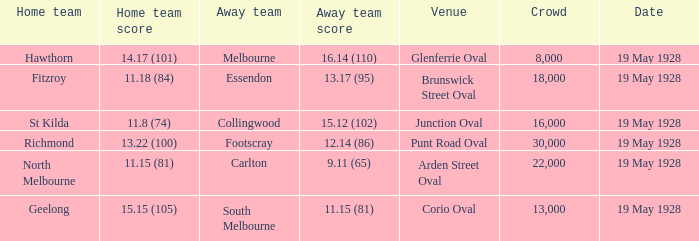What was the listed crowd at junction oval? 16000.0. 